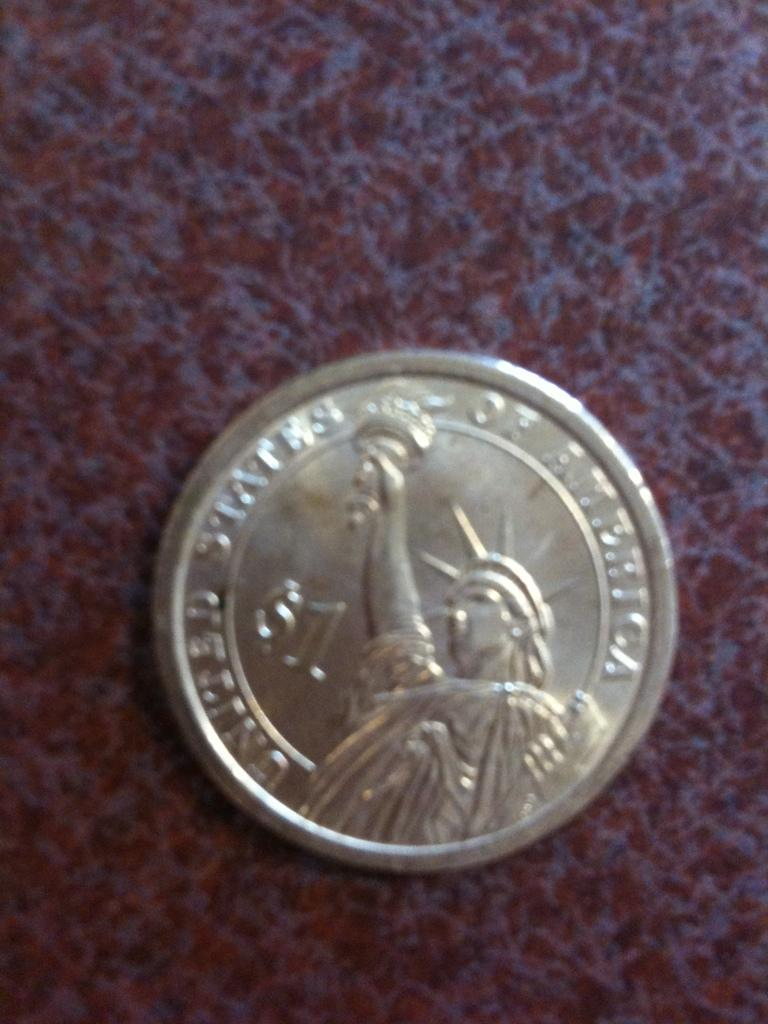Provide a one-sentence caption for the provided image. a round silver coin with the united states of america written on it. 